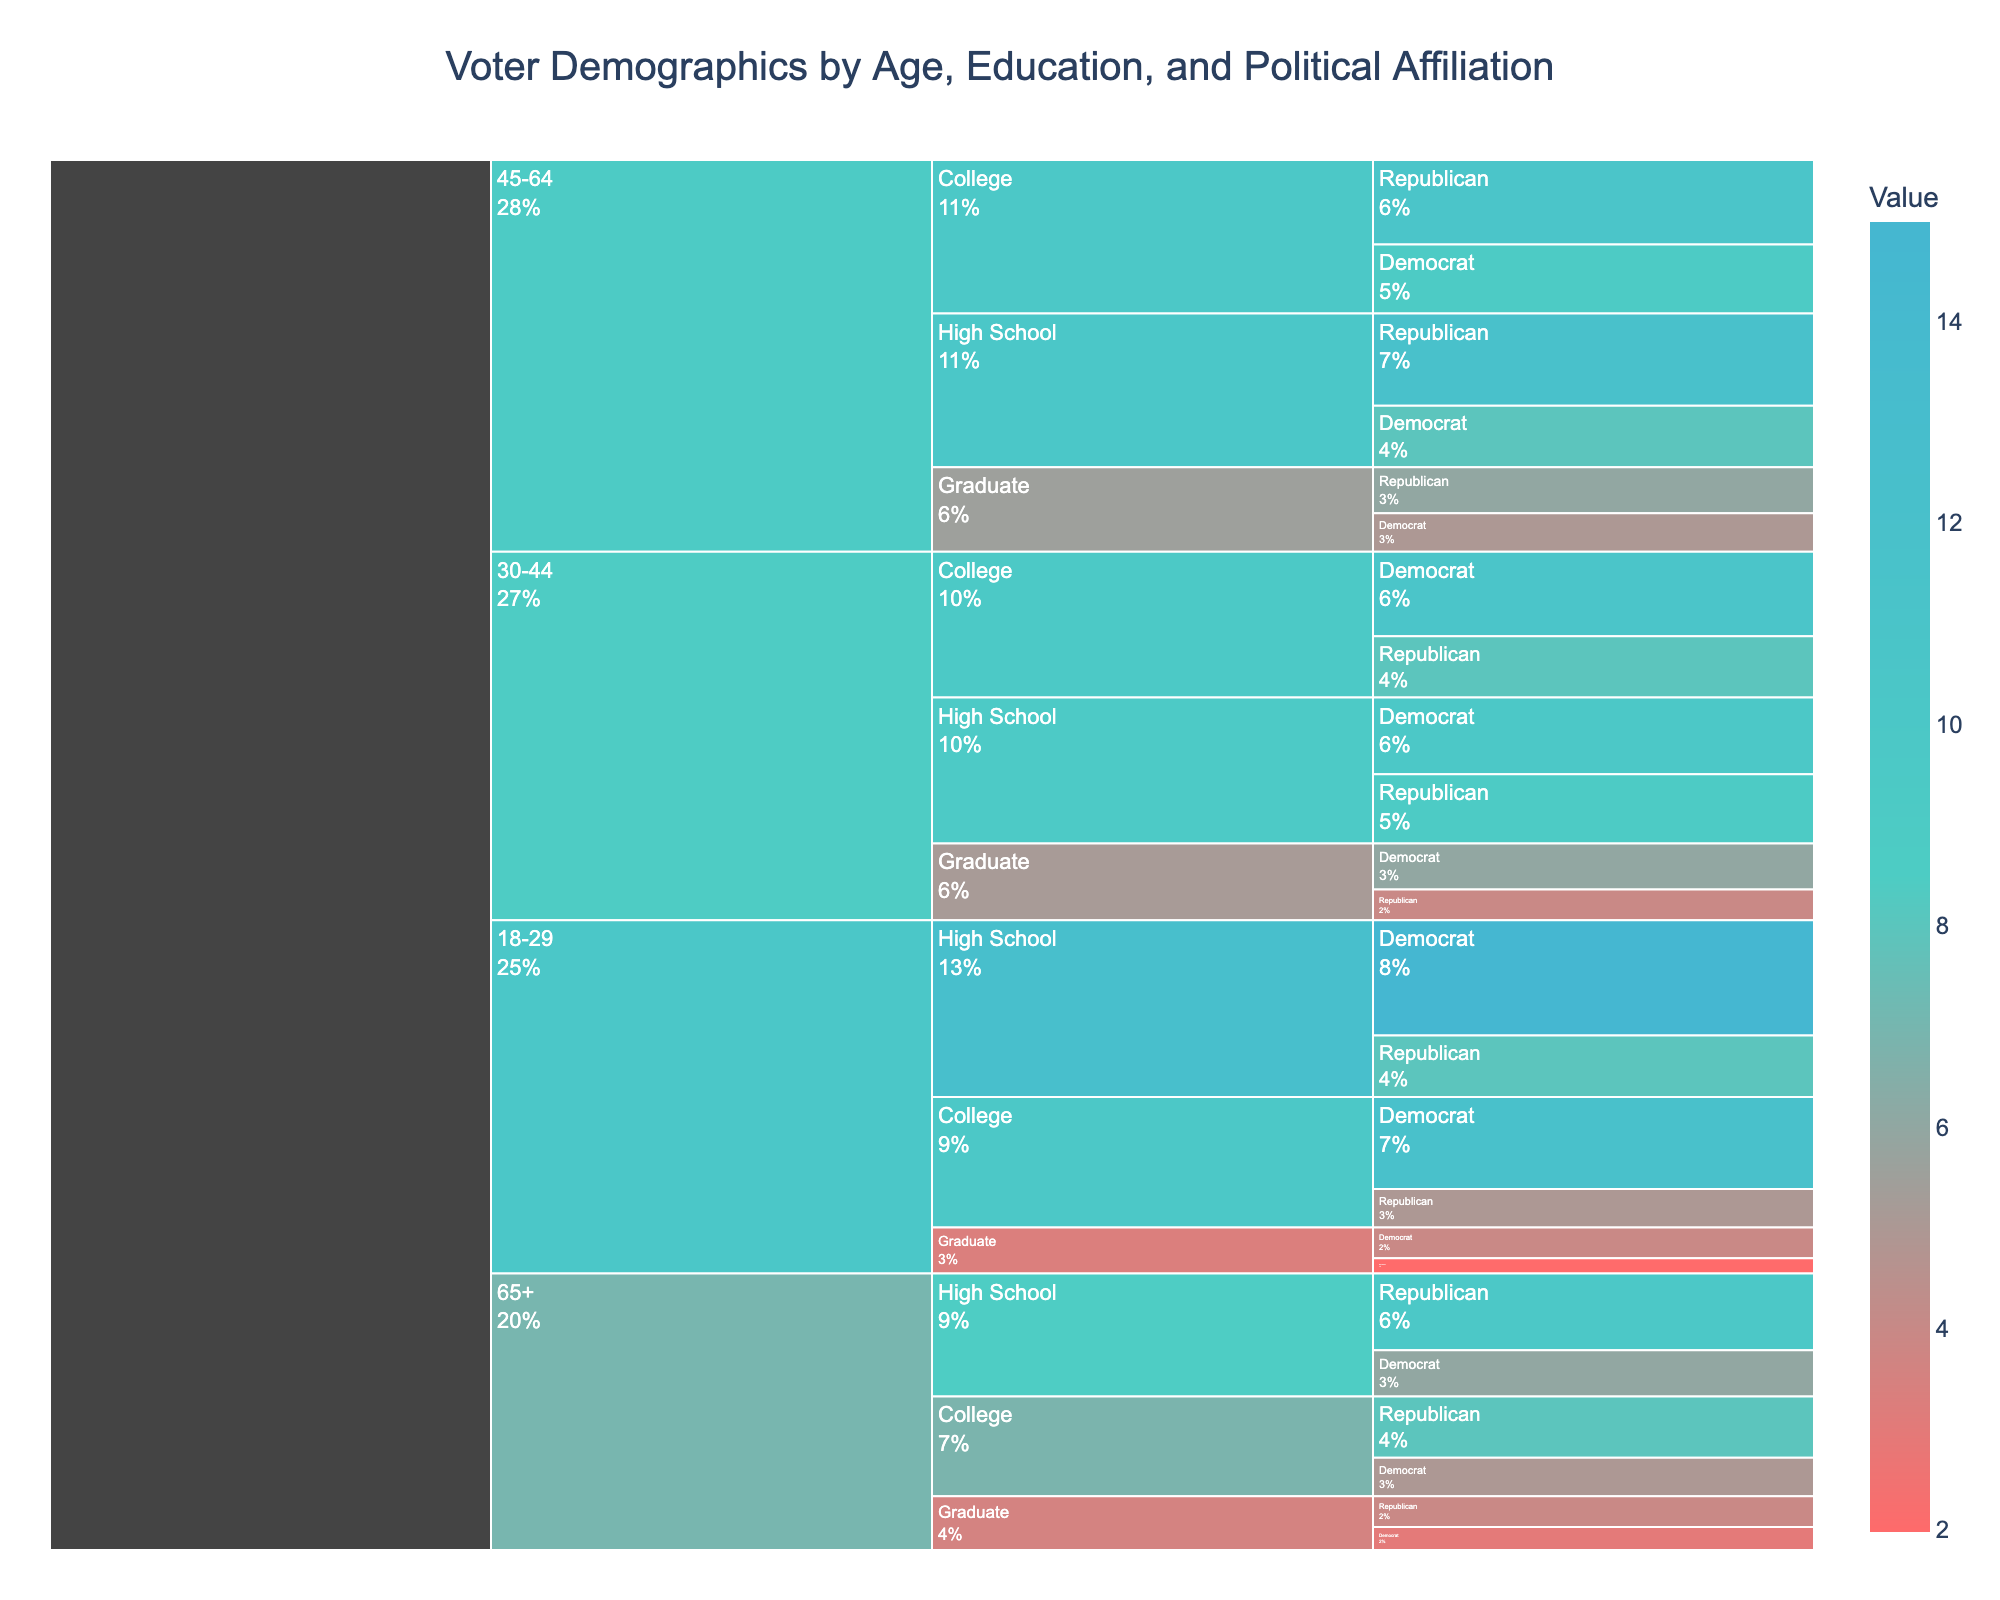What is the title of the chart? The title is indicated at the top of the chart and summarizes the content being visualized.
Answer: Voter Demographics by Age, Education, and Political Affiliation What age group has the highest percentage of Democrat voters with a high school education? Look at the segment within the "18-29" age group under "High School" education and identify the political affiliation. Compare the percentages.
Answer: 18-29 Which education group within the 45-64 age range has the highest percentage of Republican voters? Examine the "45-64" age group and compare the percentages of Republican voters within "High School," "College," and "Graduate" education levels.
Answer: High School What is the total percentage of voters aged 30-44 who are Democrats? Sum the percentages of Democrat voters with High School, College, and Graduate education levels within the 30-44 age group.
Answer: 27% Which age group, regardless of education, has the lowest percentage of total voters? Sum the individual percentages within each age group and compare the totals to find the lowest.
Answer: 65+ How do Graduate-educated Republican voters in the 45-64 age group compare in percentage to College-educated Republicans in the same group? Compare the percentages of "Graduate" and "College" education levels within the 45-64 age group for Republican voters.
Answer: Graduate (6%) is lower than College (11%) Identify the age group and education level with the lowest percentage of Republican voters. Find the segment with the lowest percentage of Republican voters by comparing all segments.
Answer: 18-29, Graduate How does the percentage of Democrat voters with a Graduate degree aged 18-29 compare to those aged 65+? Compare the specific percentages for Democrat voters with a Graduate degree between the two age groups.
Answer: 18-29 (4%) is higher than 65+ (3%) What is the combined percentage of Republican voters with a College degree in all age groups? Sum the percentages of Republican voters with a College degree across all age groups.
Answer: 32% Which group has the greater percentage of voters: College-educated Democrats aged 30-44 or High School-educated Republicans aged 45-64? Compare the percentages of College-educated Democrats aged 30-44 and High School-educated Republicans aged 45-64 to determine the greater percentage.
Answer: College-educated Democrats aged 30-44 (11%) is lower than High School-educated Republicans aged 45-64 (12%) 